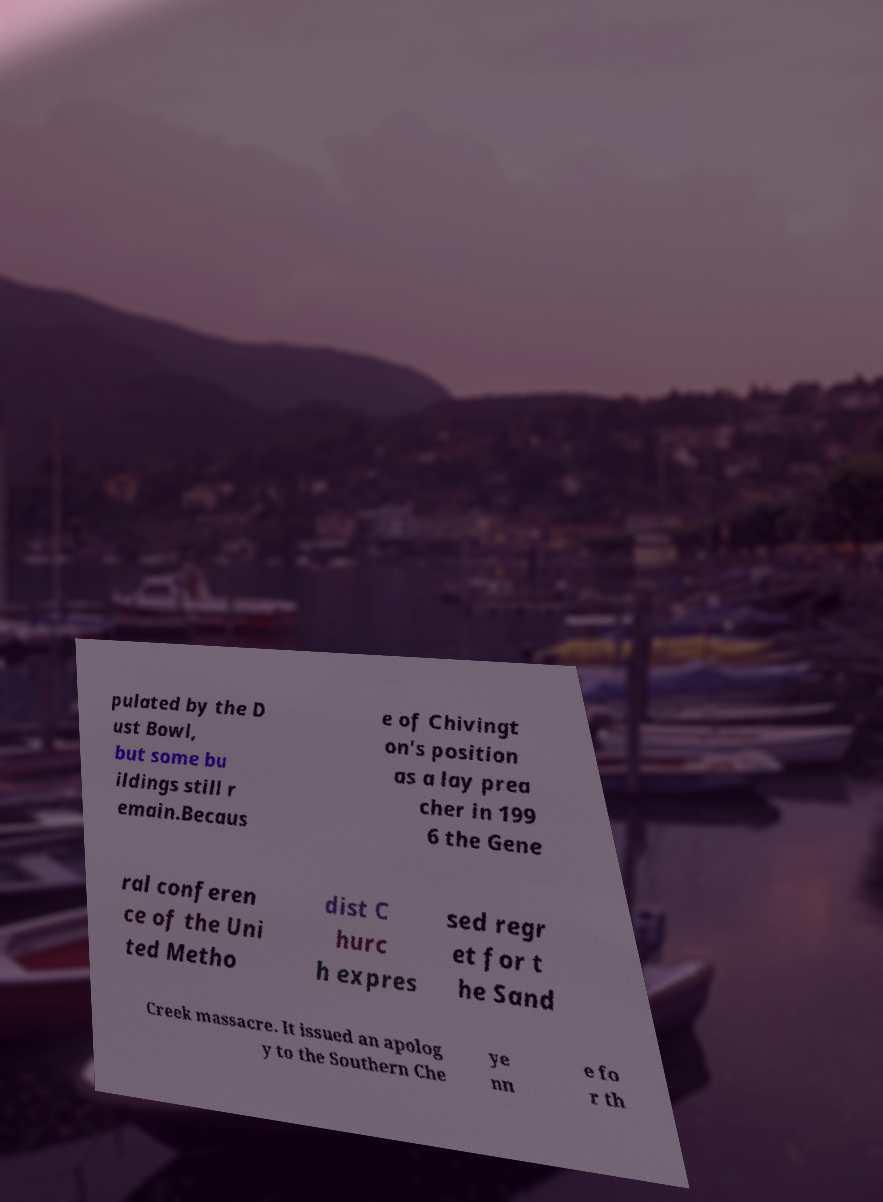I need the written content from this picture converted into text. Can you do that? pulated by the D ust Bowl, but some bu ildings still r emain.Becaus e of Chivingt on's position as a lay prea cher in 199 6 the Gene ral conferen ce of the Uni ted Metho dist C hurc h expres sed regr et for t he Sand Creek massacre. It issued an apolog y to the Southern Che ye nn e fo r th 